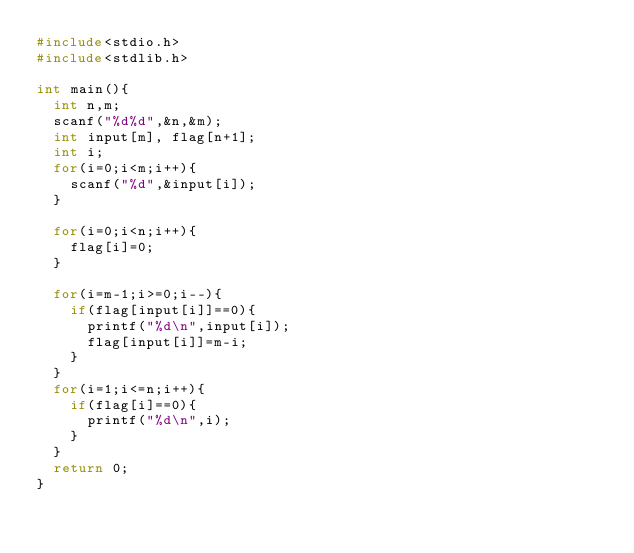<code> <loc_0><loc_0><loc_500><loc_500><_C_>#include<stdio.h>
#include<stdlib.h>
  
int main(){
  int n,m;
  scanf("%d%d",&n,&m);
  int input[m], flag[n+1];
  int i;
  for(i=0;i<m;i++){
    scanf("%d",&input[i]);
  }
  
  for(i=0;i<n;i++){
    flag[i]=0;
  }

  for(i=m-1;i>=0;i--){
    if(flag[input[i]]==0){
      printf("%d\n",input[i]);
      flag[input[i]]=m-i;
    }
  }
  for(i=1;i<=n;i++){
    if(flag[i]==0){
      printf("%d\n",i);
    }
  }
  return 0;
}</code> 